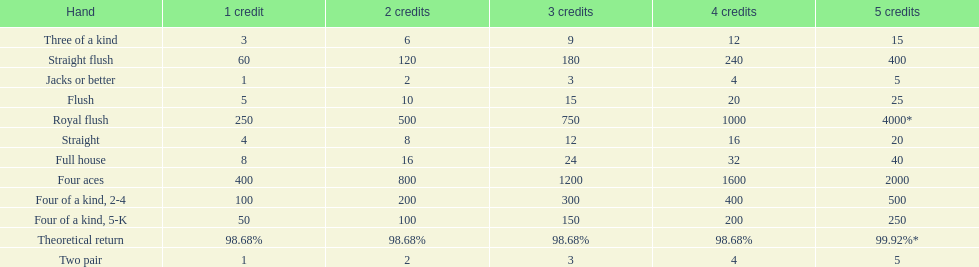Each four aces win is a multiple of what number? 400. 